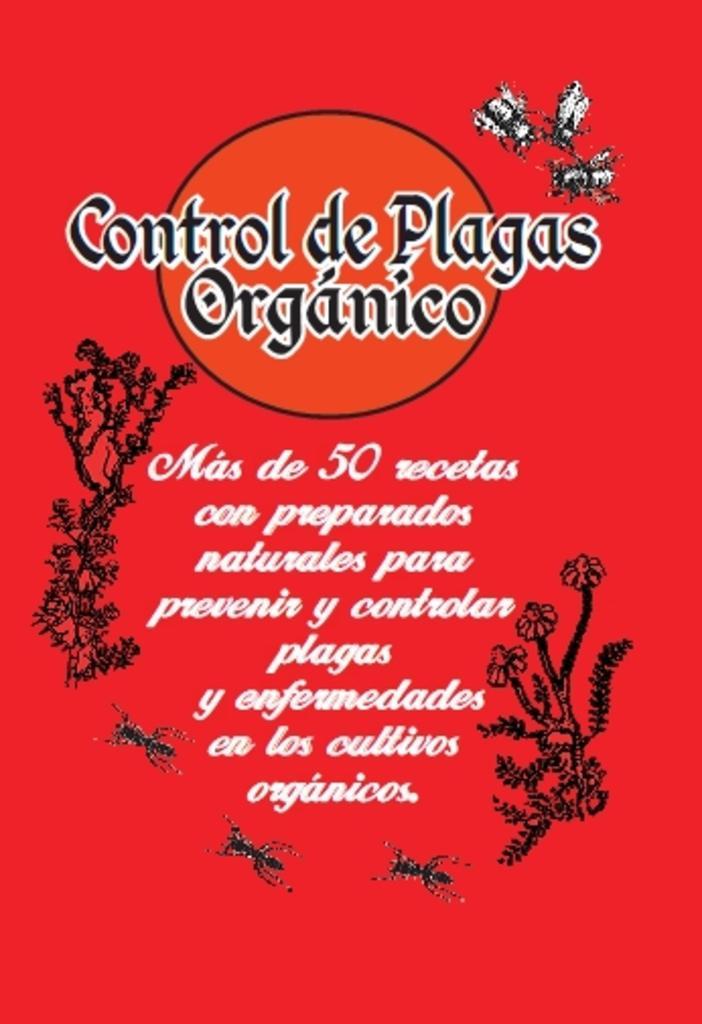Could you give a brief overview of what you see in this image? In this image I can see the pamphlet. On the pamphlet I can see an insects, flowers to the plants and something is written. 